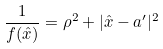Convert formula to latex. <formula><loc_0><loc_0><loc_500><loc_500>\frac { 1 } { f ( { \hat { x } } ) } = \rho ^ { 2 } + | { \hat { x } } - a ^ { \prime } | ^ { 2 }</formula> 